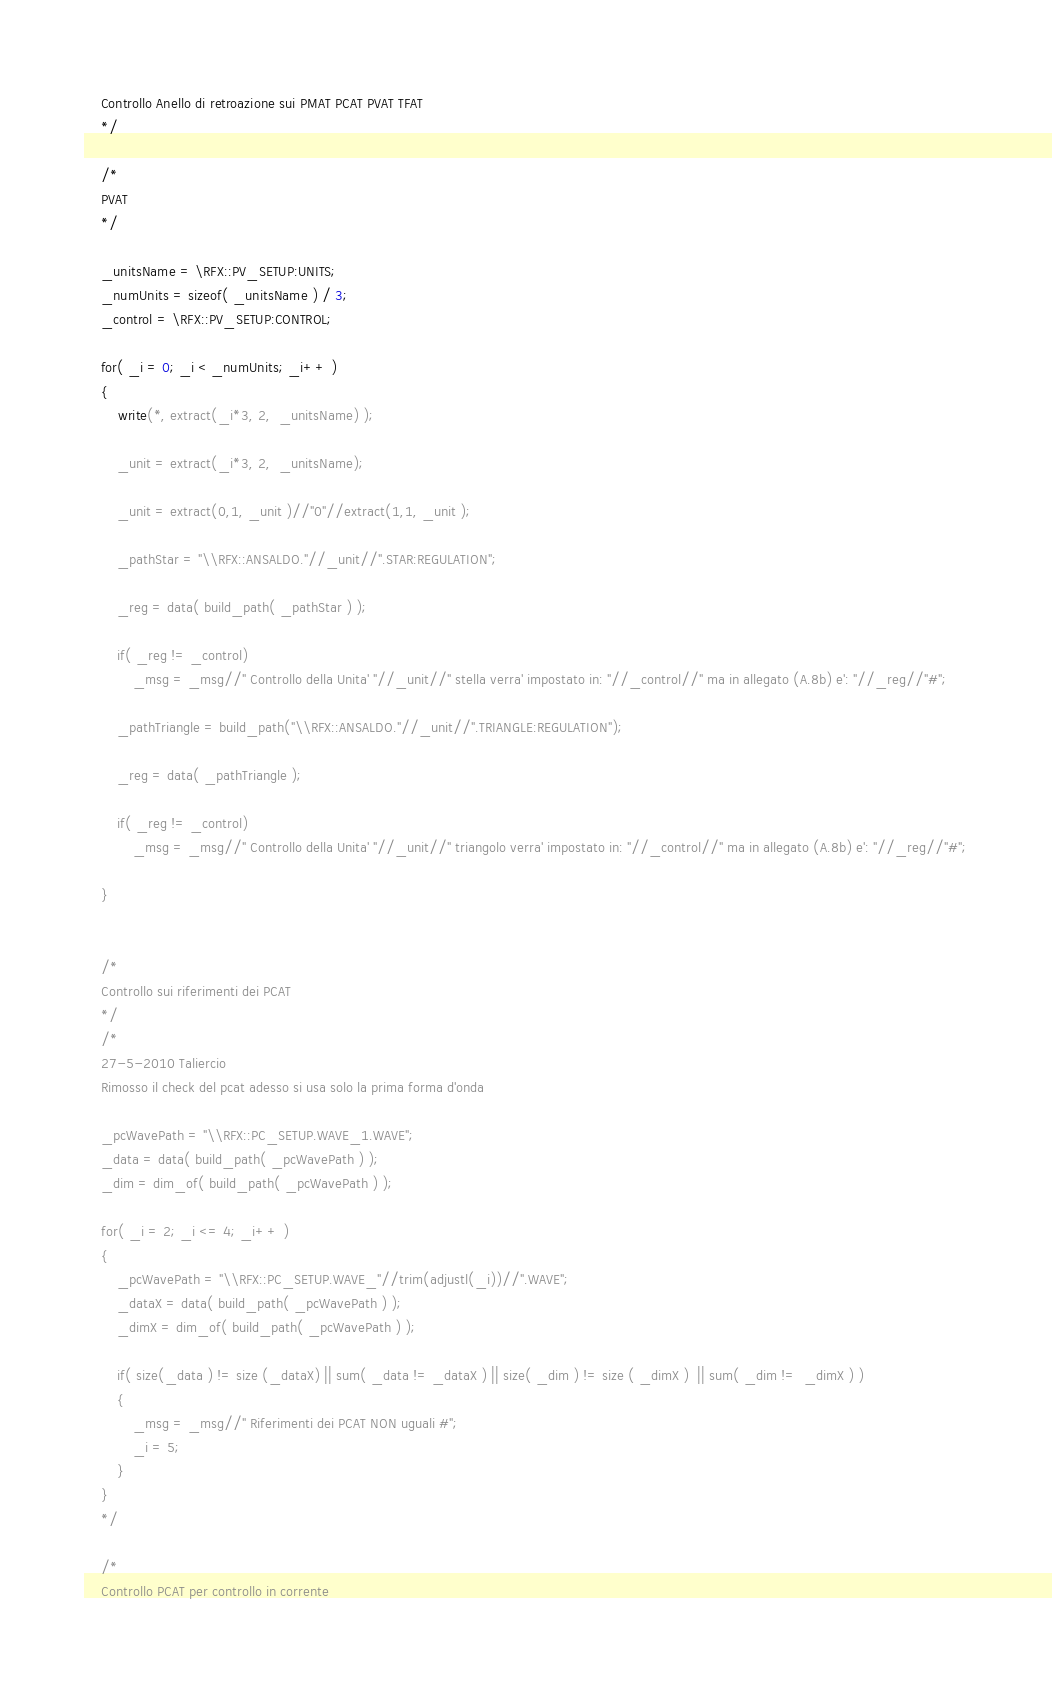<code> <loc_0><loc_0><loc_500><loc_500><_SML_>	Controllo Anello di retroazione sui PMAT PCAT PVAT TFAT
	*/

	/*
	PVAT
	*/

	_unitsName = \RFX::PV_SETUP:UNITS;
	_numUnits = sizeof( _unitsName ) / 3;
	_control = \RFX::PV_SETUP:CONTROL;

	for( _i = 0; _i < _numUnits; _i++ )
	{
		write(*, extract(_i*3, 2,  _unitsName) );
		
		_unit = extract(_i*3, 2,  _unitsName);
		
		_unit = extract(0,1, _unit )//"0"//extract(1,1, _unit );
		
		_pathStar = "\\RFX::ANSALDO."//_unit//".STAR:REGULATION";
		
		_reg = data( build_path( _pathStar ) );
		
		if( _reg != _control)
			_msg = _msg//" Controllo della Unita' "//_unit//" stella verra' impostato in: "//_control//" ma in allegato (A.8b) e': "//_reg//"#";
		
		_pathTriangle = build_path("\\RFX::ANSALDO."//_unit//".TRIANGLE:REGULATION");
		
		_reg = data( _pathTriangle );

		if( _reg != _control)
			_msg = _msg//" Controllo della Unita' "//_unit//" triangolo verra' impostato in: "//_control//" ma in allegato (A.8b) e': "//_reg//"#";
				
	}
	
	
	/*
	Controllo sui riferimenti dei PCAT 
	*/
	/*
	27-5-2010 Taliercio
	Rimosso il check del pcat adesso si usa solo la prima forma d'onda
	
	_pcWavePath = "\\RFX::PC_SETUP.WAVE_1.WAVE";
	_data = data( build_path( _pcWavePath ) );
	_dim = dim_of( build_path( _pcWavePath ) );
	
	for( _i = 2; _i <= 4; _i++ )
	{
		_pcWavePath = "\\RFX::PC_SETUP.WAVE_"//trim(adjustl(_i))//".WAVE";
		_dataX = data( build_path( _pcWavePath ) );
		_dimX = dim_of( build_path( _pcWavePath ) );
		
		if( size(_data ) != size (_dataX) || sum( _data != _dataX ) || size( _dim ) != size ( _dimX )  || sum( _dim !=  _dimX ) )
		{
			_msg = _msg//" Riferimenti dei PCAT NON uguali #";
			_i = 5;
		}		
	}
	*/
	
	/*
	Controllo PCAT per controllo in corrente</code> 